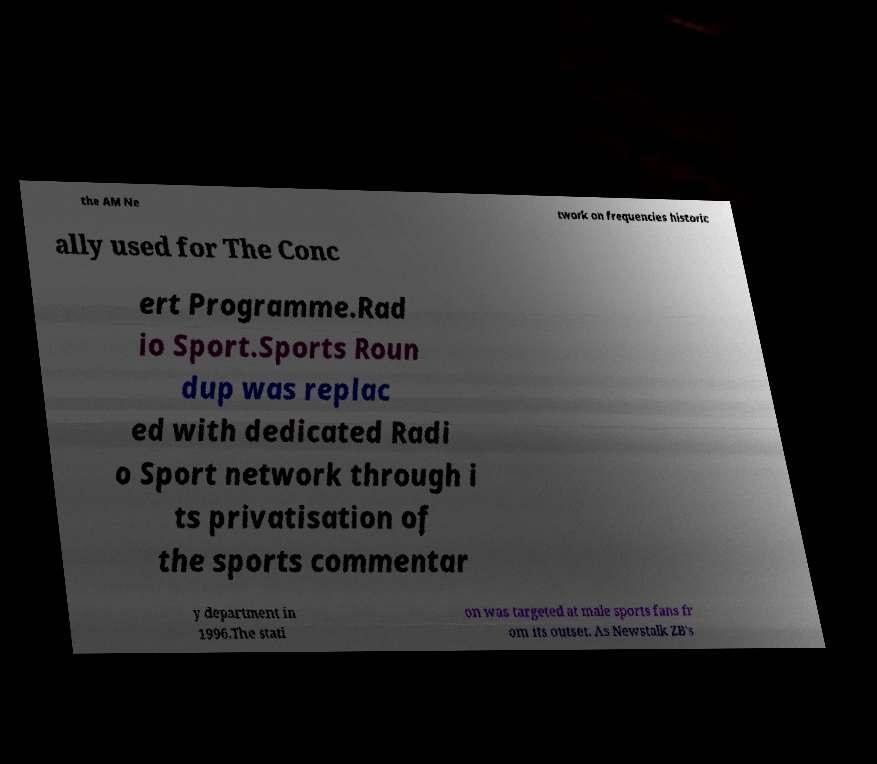Can you read and provide the text displayed in the image?This photo seems to have some interesting text. Can you extract and type it out for me? the AM Ne twork on frequencies historic ally used for The Conc ert Programme.Rad io Sport.Sports Roun dup was replac ed with dedicated Radi o Sport network through i ts privatisation of the sports commentar y department in 1996.The stati on was targeted at male sports fans fr om its outset. As Newstalk ZB's 